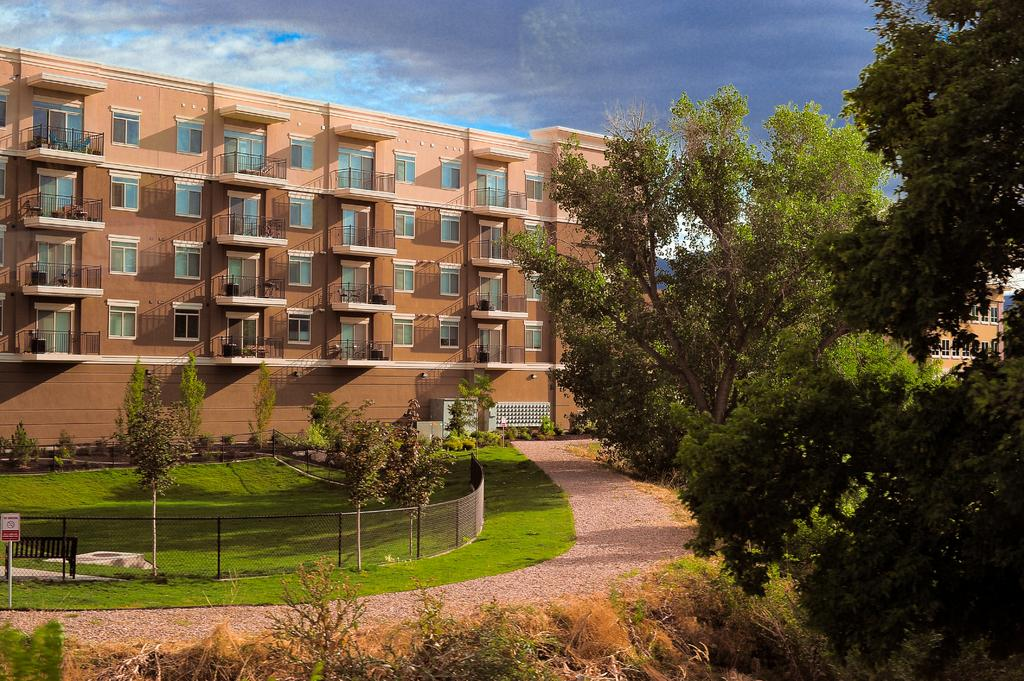What type of vegetation is present in the image? There are trees in the image. What type of seating is available in the image? There is a bench in the image. What is located on the left side of the image? There is a sign board on the left side of the image. What type of barrier is visible in the image? There is a fence in the image. What type of ground surface is present in the image? There is grass in the image. What can be seen in the background of the image? There is a building in the background. What is visible in the sky in the image? There are clouds in the sky. What type of joke is being told by the tree in the image? There is no joke being told by the tree in the image, as trees do not have the ability to tell jokes. What type of music can be heard playing in the background of the image? There is no music playing in the background of the image, as the provided facts do not mention any audio elements. 